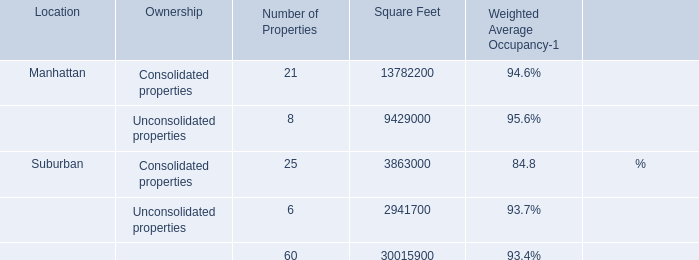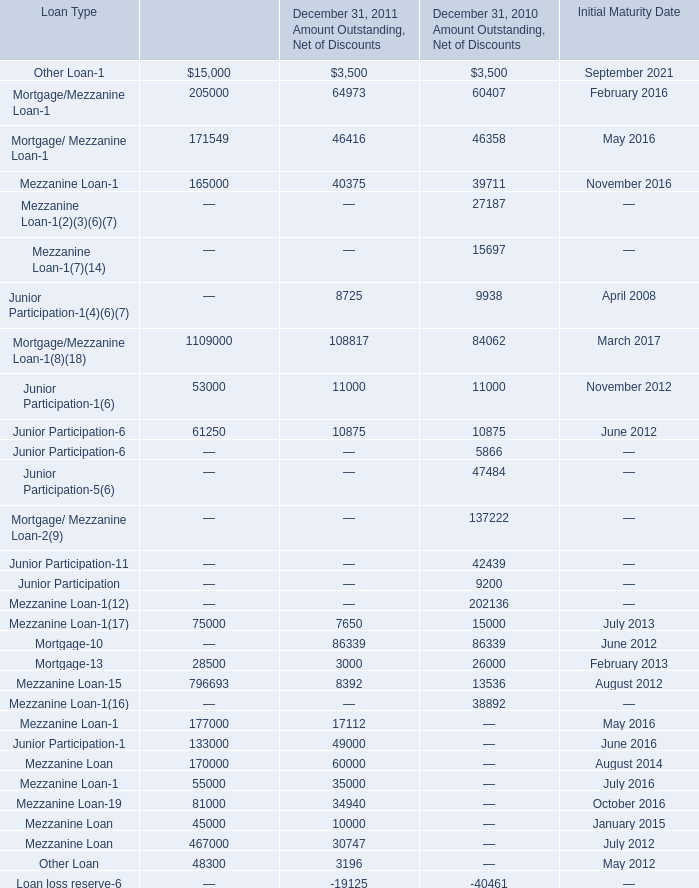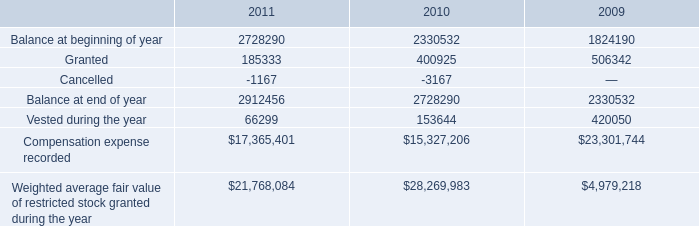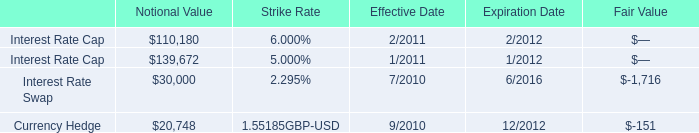What is the average amount of Interest Rate Swap of Notional Value, and Mezzanine Loan of December 31, 2011 Senior Financing ? 
Computations: ((30000.0 + 75000.0) / 2)
Answer: 52500.0. 